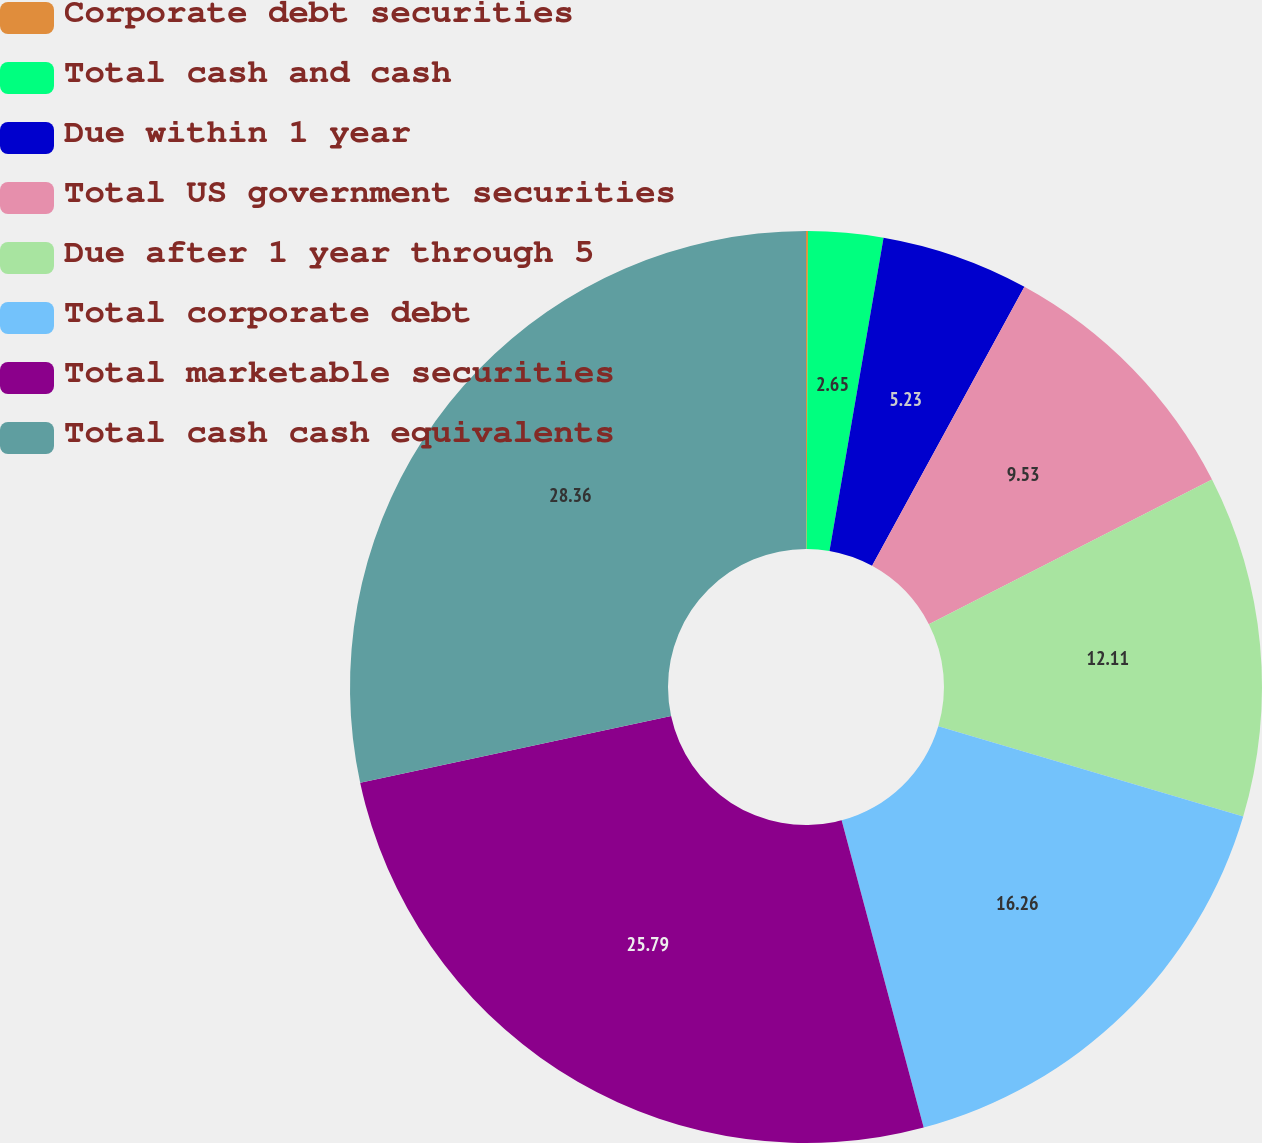Convert chart to OTSL. <chart><loc_0><loc_0><loc_500><loc_500><pie_chart><fcel>Corporate debt securities<fcel>Total cash and cash<fcel>Due within 1 year<fcel>Total US government securities<fcel>Due after 1 year through 5<fcel>Total corporate debt<fcel>Total marketable securities<fcel>Total cash cash equivalents<nl><fcel>0.07%<fcel>2.65%<fcel>5.23%<fcel>9.53%<fcel>12.11%<fcel>16.26%<fcel>25.79%<fcel>28.37%<nl></chart> 